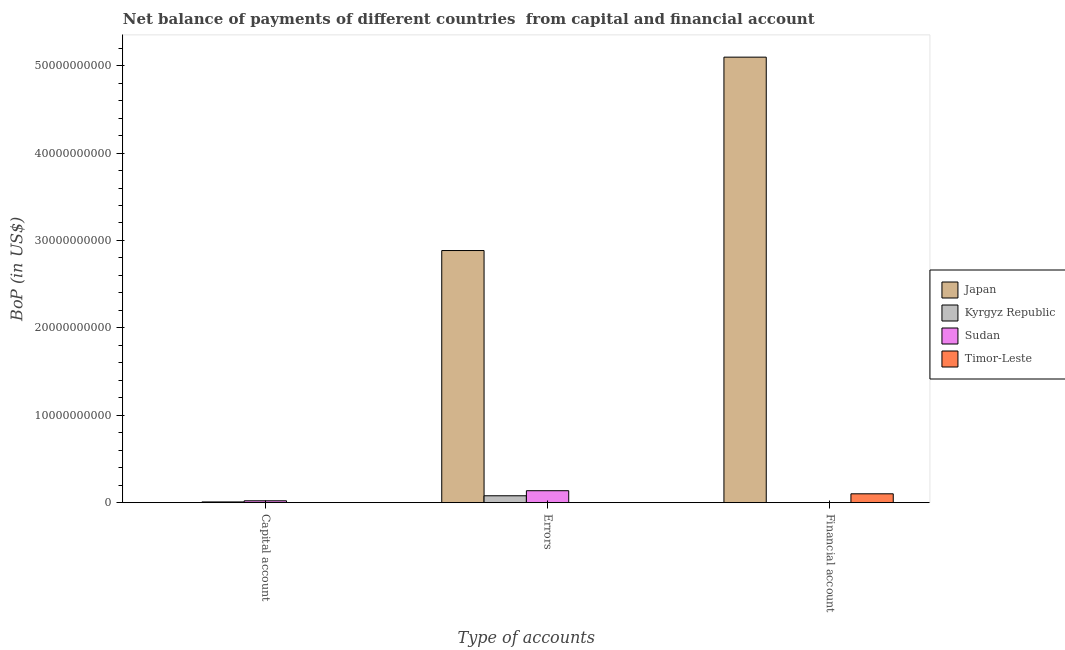How many different coloured bars are there?
Give a very brief answer. 4. How many groups of bars are there?
Keep it short and to the point. 3. Are the number of bars on each tick of the X-axis equal?
Give a very brief answer. No. How many bars are there on the 1st tick from the left?
Your answer should be very brief. 2. How many bars are there on the 2nd tick from the right?
Your response must be concise. 3. What is the label of the 1st group of bars from the left?
Ensure brevity in your answer.  Capital account. What is the amount of errors in Japan?
Provide a succinct answer. 2.88e+1. Across all countries, what is the maximum amount of financial account?
Offer a very short reply. 5.10e+1. What is the total amount of net capital account in the graph?
Your response must be concise. 2.95e+08. What is the difference between the amount of financial account in Timor-Leste and that in Japan?
Your answer should be very brief. -5.00e+1. What is the difference between the amount of net capital account in Kyrgyz Republic and the amount of errors in Timor-Leste?
Your answer should be compact. 8.19e+07. What is the average amount of financial account per country?
Make the answer very short. 1.30e+1. What is the difference between the amount of net capital account and amount of errors in Sudan?
Your response must be concise. -1.15e+09. In how many countries, is the amount of net capital account greater than 40000000000 US$?
Give a very brief answer. 0. What is the ratio of the amount of net capital account in Kyrgyz Republic to that in Sudan?
Your answer should be very brief. 0.38. What is the difference between the highest and the lowest amount of net capital account?
Provide a short and direct response. 2.13e+08. In how many countries, is the amount of net capital account greater than the average amount of net capital account taken over all countries?
Ensure brevity in your answer.  2. Is the sum of the amount of errors in Kyrgyz Republic and Japan greater than the maximum amount of financial account across all countries?
Offer a very short reply. No. Is it the case that in every country, the sum of the amount of net capital account and amount of errors is greater than the amount of financial account?
Ensure brevity in your answer.  No. How many bars are there?
Your answer should be compact. 7. Are all the bars in the graph horizontal?
Offer a terse response. No. How many countries are there in the graph?
Keep it short and to the point. 4. Does the graph contain any zero values?
Offer a terse response. Yes. Does the graph contain grids?
Keep it short and to the point. No. Where does the legend appear in the graph?
Ensure brevity in your answer.  Center right. What is the title of the graph?
Give a very brief answer. Net balance of payments of different countries  from capital and financial account. What is the label or title of the X-axis?
Offer a very short reply. Type of accounts. What is the label or title of the Y-axis?
Your response must be concise. BoP (in US$). What is the BoP (in US$) of Kyrgyz Republic in Capital account?
Provide a short and direct response. 8.19e+07. What is the BoP (in US$) in Sudan in Capital account?
Your answer should be compact. 2.13e+08. What is the BoP (in US$) in Japan in Errors?
Your answer should be compact. 2.88e+1. What is the BoP (in US$) of Kyrgyz Republic in Errors?
Your answer should be compact. 7.87e+08. What is the BoP (in US$) of Sudan in Errors?
Keep it short and to the point. 1.37e+09. What is the BoP (in US$) of Japan in Financial account?
Your answer should be compact. 5.10e+1. What is the BoP (in US$) of Timor-Leste in Financial account?
Your answer should be compact. 1.01e+09. Across all Type of accounts, what is the maximum BoP (in US$) of Japan?
Offer a very short reply. 5.10e+1. Across all Type of accounts, what is the maximum BoP (in US$) in Kyrgyz Republic?
Make the answer very short. 7.87e+08. Across all Type of accounts, what is the maximum BoP (in US$) in Sudan?
Offer a very short reply. 1.37e+09. Across all Type of accounts, what is the maximum BoP (in US$) of Timor-Leste?
Give a very brief answer. 1.01e+09. Across all Type of accounts, what is the minimum BoP (in US$) in Sudan?
Provide a short and direct response. 0. What is the total BoP (in US$) of Japan in the graph?
Provide a short and direct response. 7.98e+1. What is the total BoP (in US$) in Kyrgyz Republic in the graph?
Keep it short and to the point. 8.69e+08. What is the total BoP (in US$) in Sudan in the graph?
Keep it short and to the point. 1.58e+09. What is the total BoP (in US$) in Timor-Leste in the graph?
Your response must be concise. 1.01e+09. What is the difference between the BoP (in US$) of Kyrgyz Republic in Capital account and that in Errors?
Your response must be concise. -7.05e+08. What is the difference between the BoP (in US$) in Sudan in Capital account and that in Errors?
Provide a succinct answer. -1.15e+09. What is the difference between the BoP (in US$) in Japan in Errors and that in Financial account?
Offer a very short reply. -2.21e+1. What is the difference between the BoP (in US$) of Kyrgyz Republic in Capital account and the BoP (in US$) of Sudan in Errors?
Your answer should be compact. -1.28e+09. What is the difference between the BoP (in US$) of Kyrgyz Republic in Capital account and the BoP (in US$) of Timor-Leste in Financial account?
Your response must be concise. -9.29e+08. What is the difference between the BoP (in US$) in Sudan in Capital account and the BoP (in US$) in Timor-Leste in Financial account?
Your answer should be compact. -7.98e+08. What is the difference between the BoP (in US$) in Japan in Errors and the BoP (in US$) in Timor-Leste in Financial account?
Your response must be concise. 2.78e+1. What is the difference between the BoP (in US$) in Kyrgyz Republic in Errors and the BoP (in US$) in Timor-Leste in Financial account?
Ensure brevity in your answer.  -2.24e+08. What is the difference between the BoP (in US$) in Sudan in Errors and the BoP (in US$) in Timor-Leste in Financial account?
Your answer should be very brief. 3.55e+08. What is the average BoP (in US$) of Japan per Type of accounts?
Provide a succinct answer. 2.66e+1. What is the average BoP (in US$) of Kyrgyz Republic per Type of accounts?
Provide a short and direct response. 2.90e+08. What is the average BoP (in US$) in Sudan per Type of accounts?
Ensure brevity in your answer.  5.26e+08. What is the average BoP (in US$) of Timor-Leste per Type of accounts?
Offer a terse response. 3.37e+08. What is the difference between the BoP (in US$) of Kyrgyz Republic and BoP (in US$) of Sudan in Capital account?
Offer a very short reply. -1.31e+08. What is the difference between the BoP (in US$) of Japan and BoP (in US$) of Kyrgyz Republic in Errors?
Make the answer very short. 2.81e+1. What is the difference between the BoP (in US$) of Japan and BoP (in US$) of Sudan in Errors?
Ensure brevity in your answer.  2.75e+1. What is the difference between the BoP (in US$) in Kyrgyz Republic and BoP (in US$) in Sudan in Errors?
Your answer should be very brief. -5.79e+08. What is the difference between the BoP (in US$) of Japan and BoP (in US$) of Timor-Leste in Financial account?
Give a very brief answer. 5.00e+1. What is the ratio of the BoP (in US$) in Kyrgyz Republic in Capital account to that in Errors?
Offer a terse response. 0.1. What is the ratio of the BoP (in US$) of Sudan in Capital account to that in Errors?
Ensure brevity in your answer.  0.16. What is the ratio of the BoP (in US$) in Japan in Errors to that in Financial account?
Make the answer very short. 0.57. What is the difference between the highest and the lowest BoP (in US$) in Japan?
Your response must be concise. 5.10e+1. What is the difference between the highest and the lowest BoP (in US$) of Kyrgyz Republic?
Provide a short and direct response. 7.87e+08. What is the difference between the highest and the lowest BoP (in US$) of Sudan?
Your answer should be very brief. 1.37e+09. What is the difference between the highest and the lowest BoP (in US$) in Timor-Leste?
Keep it short and to the point. 1.01e+09. 